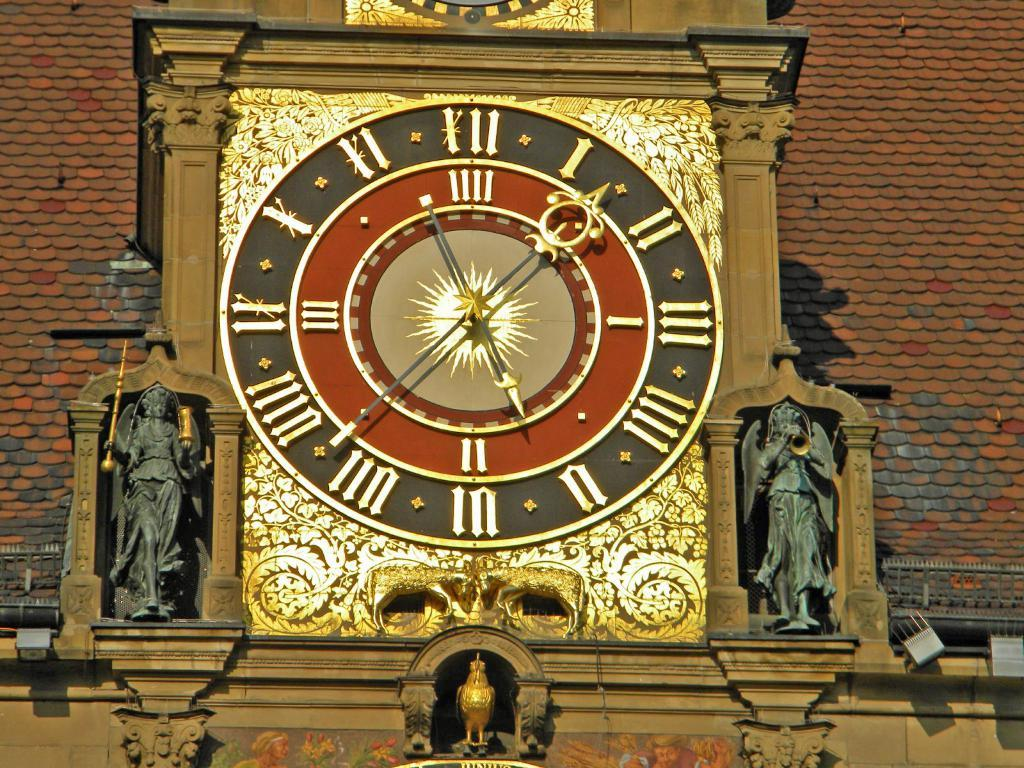Provide a one-sentence caption for the provided image. A large clock with Roman numerals also has a I next to the number 3, and II next to 6, and III next to the nine on the clock. 